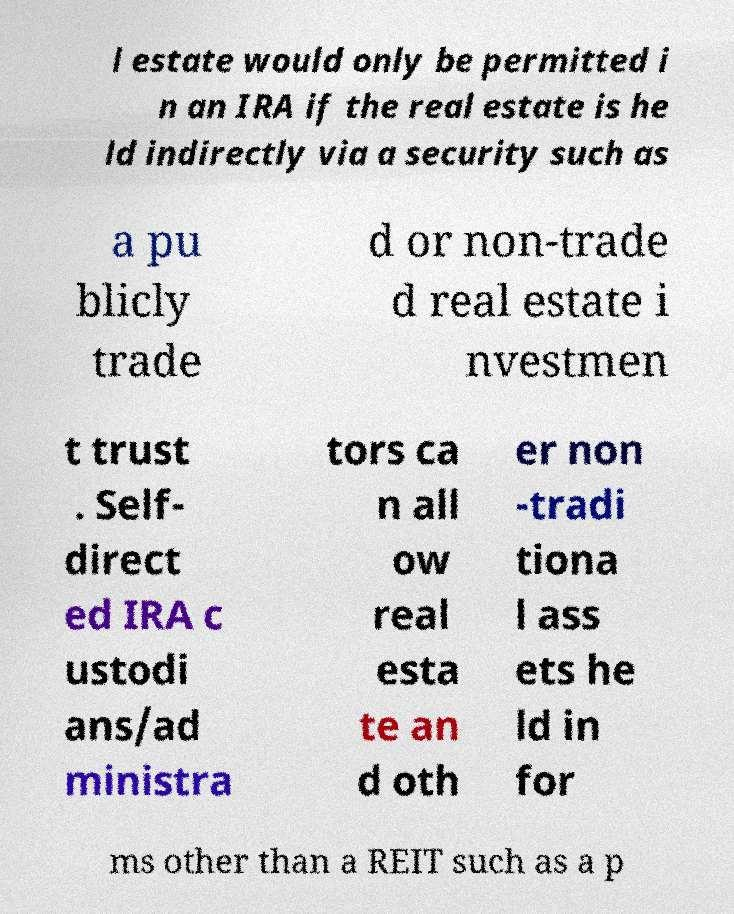Can you read and provide the text displayed in the image?This photo seems to have some interesting text. Can you extract and type it out for me? l estate would only be permitted i n an IRA if the real estate is he ld indirectly via a security such as a pu blicly trade d or non-trade d real estate i nvestmen t trust . Self- direct ed IRA c ustodi ans/ad ministra tors ca n all ow real esta te an d oth er non -tradi tiona l ass ets he ld in for ms other than a REIT such as a p 